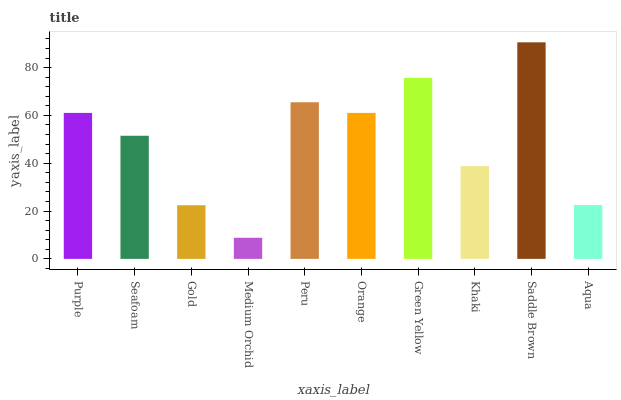Is Medium Orchid the minimum?
Answer yes or no. Yes. Is Saddle Brown the maximum?
Answer yes or no. Yes. Is Seafoam the minimum?
Answer yes or no. No. Is Seafoam the maximum?
Answer yes or no. No. Is Purple greater than Seafoam?
Answer yes or no. Yes. Is Seafoam less than Purple?
Answer yes or no. Yes. Is Seafoam greater than Purple?
Answer yes or no. No. Is Purple less than Seafoam?
Answer yes or no. No. Is Orange the high median?
Answer yes or no. Yes. Is Seafoam the low median?
Answer yes or no. Yes. Is Aqua the high median?
Answer yes or no. No. Is Medium Orchid the low median?
Answer yes or no. No. 